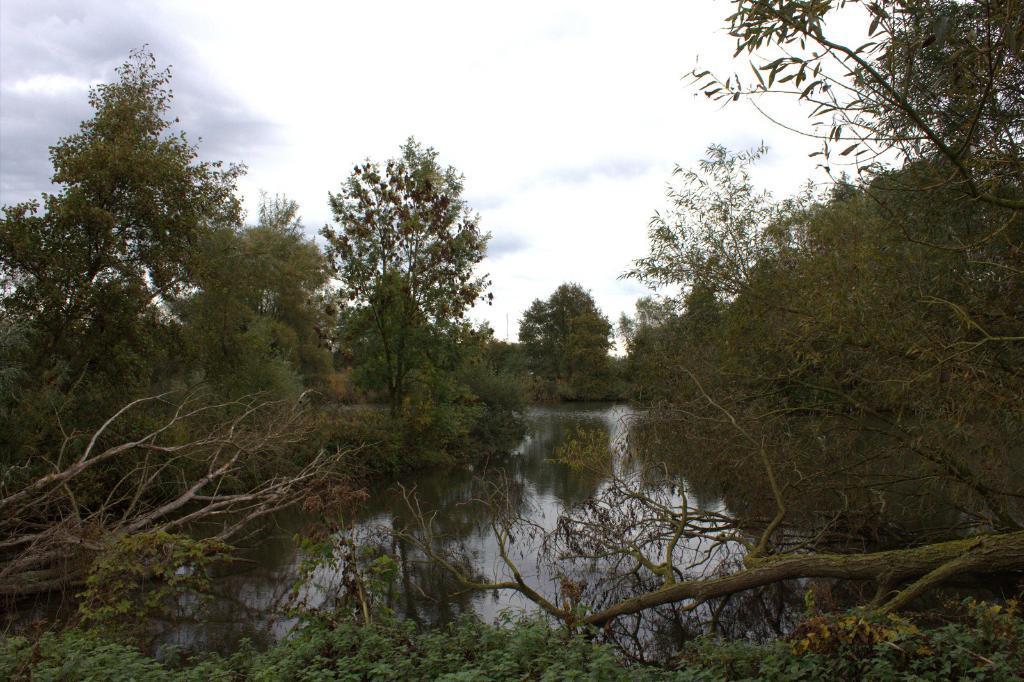How would you summarize this image in a sentence or two? At the bottom we can see trees and water. In the background we can see trees and clouds in the sky. 